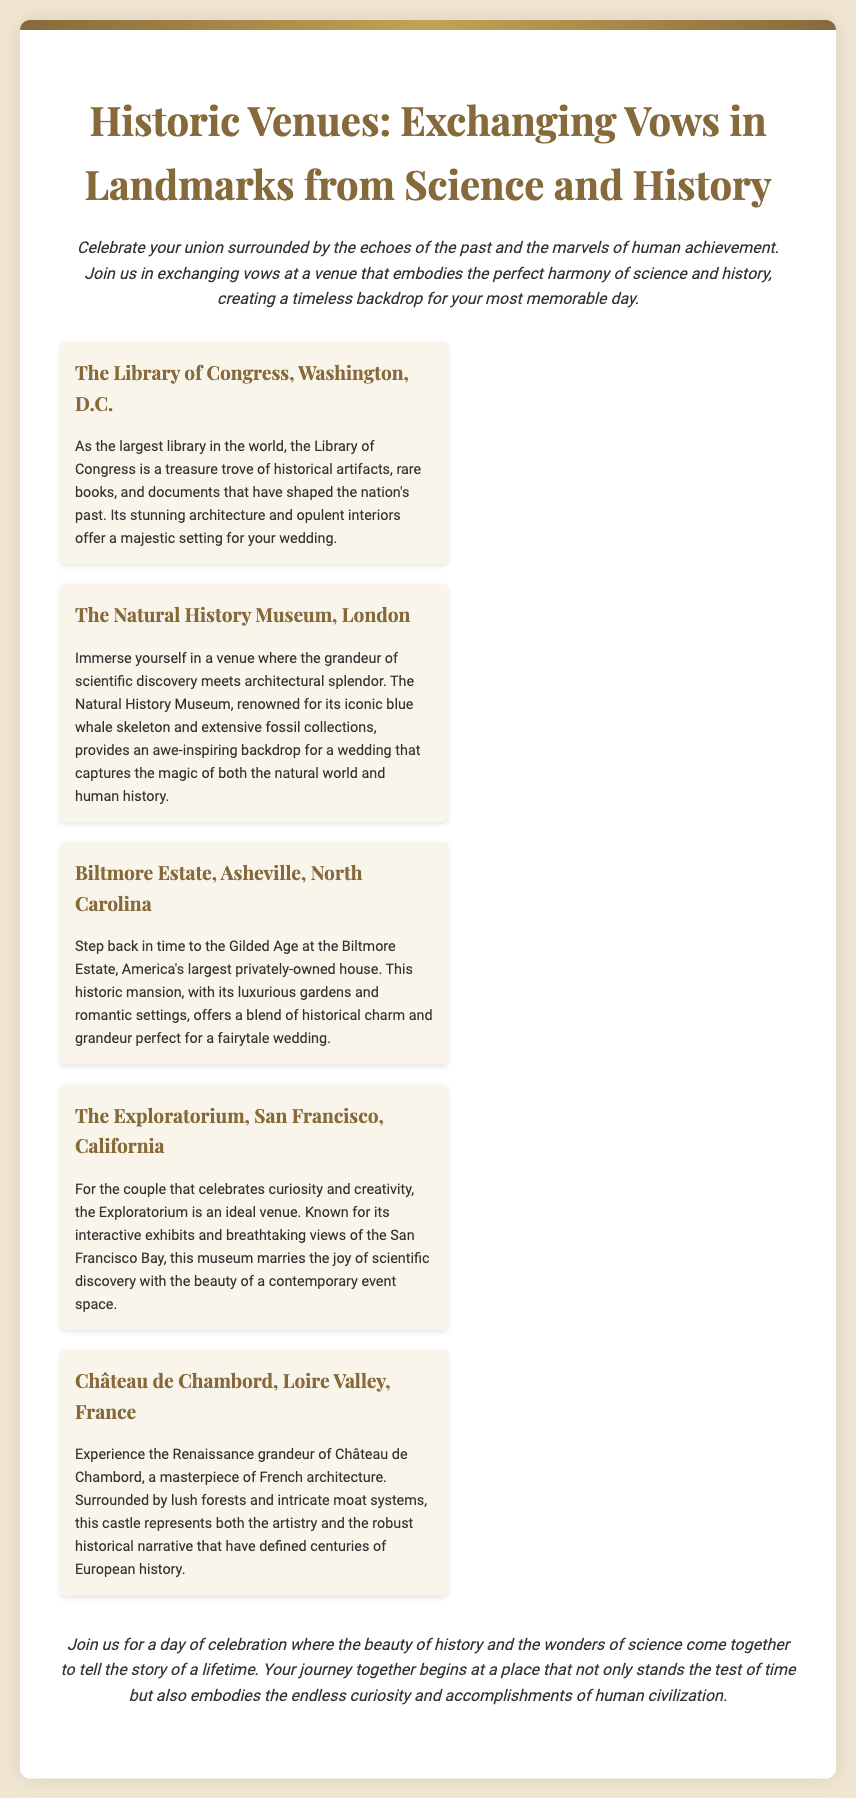What is the title of the wedding invitation? The title of the wedding invitation is prominently displayed at the top of the document.
Answer: Historic Venues: Exchanging Vows in Landmarks from Science and History What is the location of The Library of Congress? The location is specified in the document, highlighting its geographical significance.
Answer: Washington, D.C Which venue is known for its iconic blue whale skeleton? The document mentions specific venues along with notable features associated with them.
Answer: The Natural History Museum, London What type of event is being celebrated? The invitation outlines the purpose of gathering, which is central to the theme.
Answer: Wedding What does the Biltmore Estate represent? The description highlights the historical context of this specific venue.
Answer: Gilded Age How many venues are described in the invitation? The venues are listed in a numbered format, facilitating easy counting.
Answer: Five What is the unique feature of The Exploratorium? The invitation details the characteristics that make this venue stand out.
Answer: Interactive exhibits What kind of setting does Château de Chambord offer? The historical narrative includes the features associated with the venue.
Answer: Renaissance grandeur 